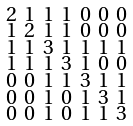<formula> <loc_0><loc_0><loc_500><loc_500>\begin{smallmatrix} 2 & 1 & 1 & 1 & 0 & 0 & 0 \\ 1 & 2 & 1 & 1 & 0 & 0 & 0 \\ 1 & 1 & 3 & 1 & 1 & 1 & 1 \\ 1 & 1 & 1 & 3 & 1 & 0 & 0 \\ 0 & 0 & 1 & 1 & 3 & 1 & 1 \\ 0 & 0 & 1 & 0 & 1 & 3 & 1 \\ 0 & 0 & 1 & 0 & 1 & 1 & 3 \end{smallmatrix}</formula> 